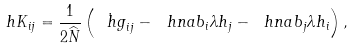Convert formula to latex. <formula><loc_0><loc_0><loc_500><loc_500>\ h K _ { i j } = \frac { 1 } { 2 \widehat { N } } \left ( \dot { \ h g } _ { i j } - \ h n a b _ { i } \lambda h _ { j } - \ h n a b _ { j } \lambda h _ { i } \right ) ,</formula> 